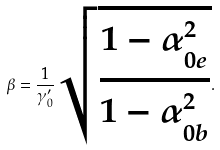Convert formula to latex. <formula><loc_0><loc_0><loc_500><loc_500>\beta = \frac { 1 } { \gamma _ { 0 } ^ { \prime } } \sqrt { \frac { 1 - \alpha _ { 0 e } ^ { 2 } } { 1 - \alpha _ { 0 b } ^ { 2 } } } .</formula> 